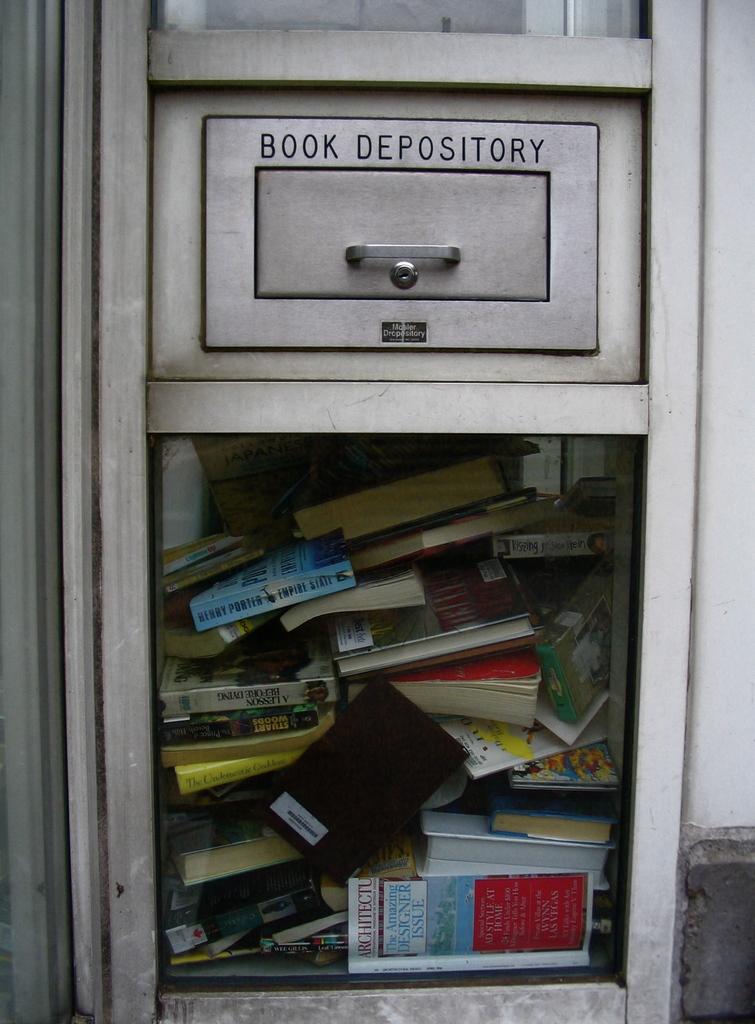What kind of depository is it?
Your answer should be compact. Book. What kind of depository?
Give a very brief answer. Book. 